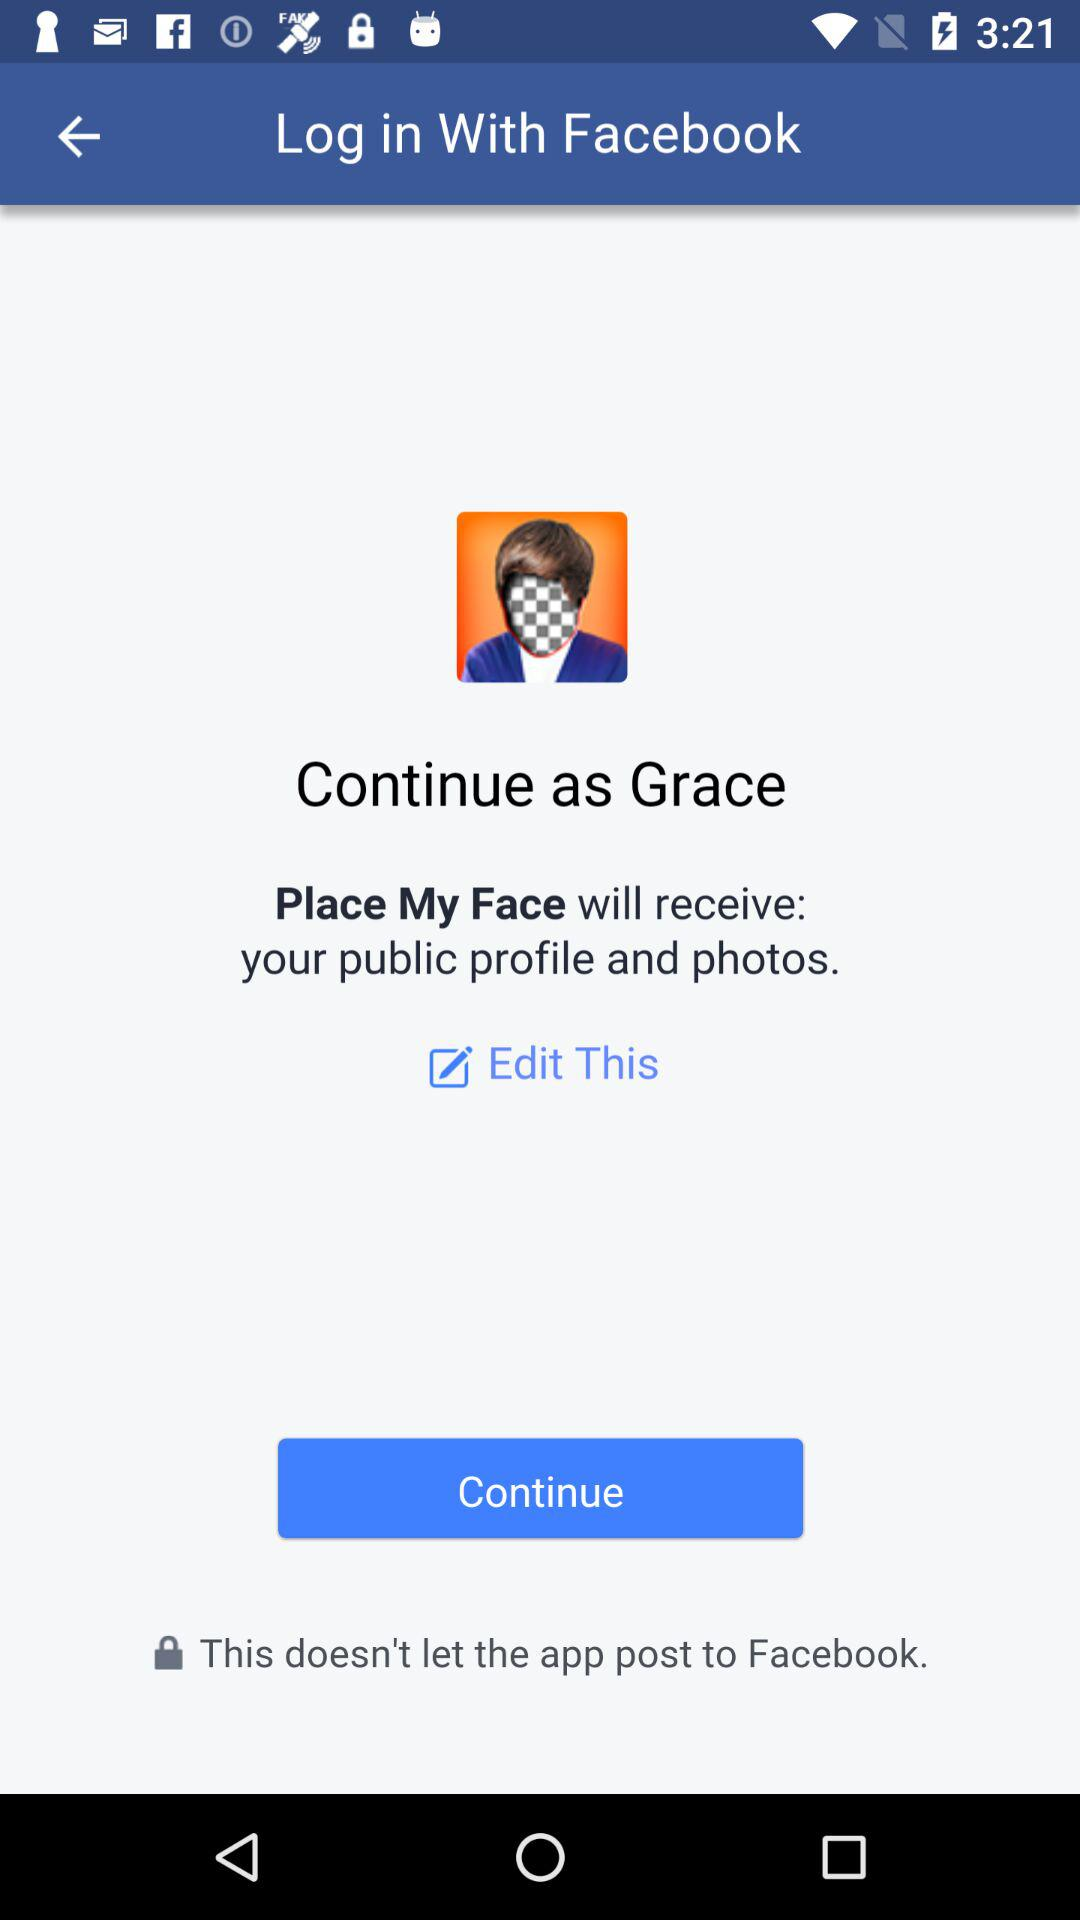What is the user name? The user name is Grace. 